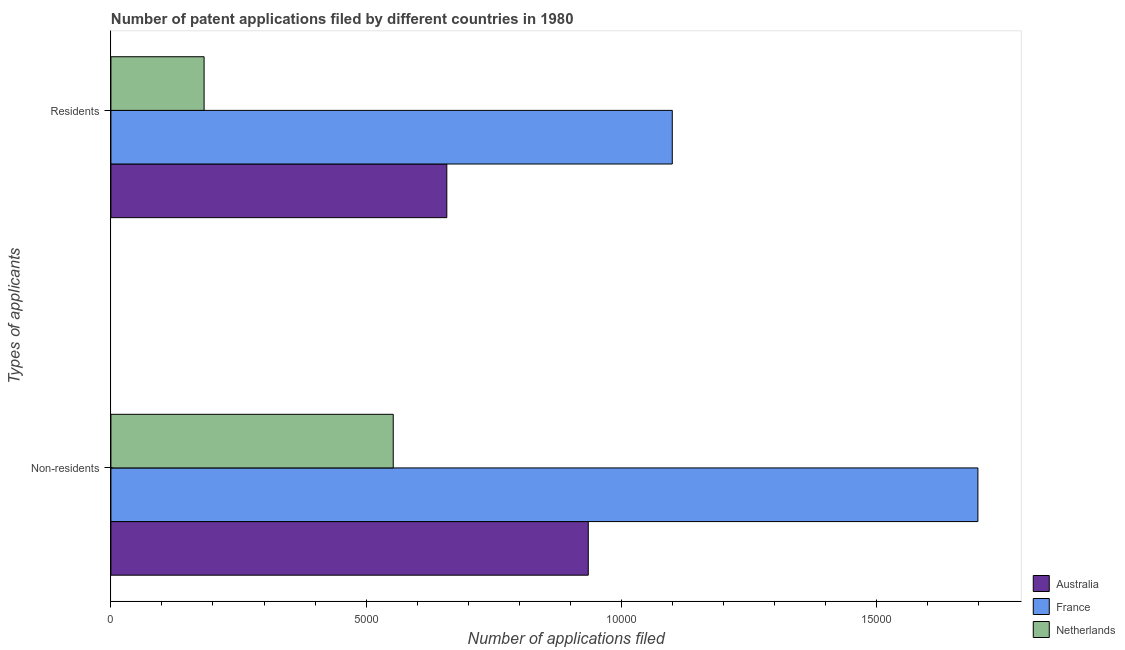How many different coloured bars are there?
Ensure brevity in your answer.  3. Are the number of bars per tick equal to the number of legend labels?
Your answer should be very brief. Yes. Are the number of bars on each tick of the Y-axis equal?
Your answer should be compact. Yes. What is the label of the 2nd group of bars from the top?
Keep it short and to the point. Non-residents. What is the number of patent applications by non residents in Australia?
Offer a very short reply. 9354. Across all countries, what is the maximum number of patent applications by non residents?
Offer a terse response. 1.70e+04. Across all countries, what is the minimum number of patent applications by residents?
Offer a very short reply. 1826. In which country was the number of patent applications by non residents maximum?
Keep it short and to the point. France. What is the total number of patent applications by residents in the graph?
Keep it short and to the point. 1.94e+04. What is the difference between the number of patent applications by residents in France and that in Netherlands?
Keep it short and to the point. 9174. What is the difference between the number of patent applications by residents in Australia and the number of patent applications by non residents in France?
Offer a terse response. -1.04e+04. What is the average number of patent applications by non residents per country?
Offer a terse response. 1.06e+04. What is the difference between the number of patent applications by residents and number of patent applications by non residents in France?
Provide a succinct answer. -5989. In how many countries, is the number of patent applications by non residents greater than 12000 ?
Provide a short and direct response. 1. What is the ratio of the number of patent applications by non residents in Australia to that in France?
Offer a terse response. 0.55. In how many countries, is the number of patent applications by residents greater than the average number of patent applications by residents taken over all countries?
Give a very brief answer. 2. What does the 1st bar from the top in Residents represents?
Your response must be concise. Netherlands. How many bars are there?
Your response must be concise. 6. What is the difference between two consecutive major ticks on the X-axis?
Give a very brief answer. 5000. Are the values on the major ticks of X-axis written in scientific E-notation?
Ensure brevity in your answer.  No. Does the graph contain grids?
Your answer should be compact. No. What is the title of the graph?
Provide a succinct answer. Number of patent applications filed by different countries in 1980. What is the label or title of the X-axis?
Your response must be concise. Number of applications filed. What is the label or title of the Y-axis?
Provide a short and direct response. Types of applicants. What is the Number of applications filed of Australia in Non-residents?
Make the answer very short. 9354. What is the Number of applications filed of France in Non-residents?
Provide a short and direct response. 1.70e+04. What is the Number of applications filed of Netherlands in Non-residents?
Your response must be concise. 5532. What is the Number of applications filed of Australia in Residents?
Provide a short and direct response. 6582. What is the Number of applications filed in France in Residents?
Offer a very short reply. 1.10e+04. What is the Number of applications filed in Netherlands in Residents?
Offer a very short reply. 1826. Across all Types of applicants, what is the maximum Number of applications filed of Australia?
Provide a short and direct response. 9354. Across all Types of applicants, what is the maximum Number of applications filed of France?
Offer a very short reply. 1.70e+04. Across all Types of applicants, what is the maximum Number of applications filed of Netherlands?
Ensure brevity in your answer.  5532. Across all Types of applicants, what is the minimum Number of applications filed in Australia?
Your response must be concise. 6582. Across all Types of applicants, what is the minimum Number of applications filed of France?
Keep it short and to the point. 1.10e+04. Across all Types of applicants, what is the minimum Number of applications filed in Netherlands?
Offer a terse response. 1826. What is the total Number of applications filed in Australia in the graph?
Keep it short and to the point. 1.59e+04. What is the total Number of applications filed of France in the graph?
Keep it short and to the point. 2.80e+04. What is the total Number of applications filed in Netherlands in the graph?
Provide a succinct answer. 7358. What is the difference between the Number of applications filed of Australia in Non-residents and that in Residents?
Your answer should be very brief. 2772. What is the difference between the Number of applications filed in France in Non-residents and that in Residents?
Offer a terse response. 5989. What is the difference between the Number of applications filed of Netherlands in Non-residents and that in Residents?
Offer a terse response. 3706. What is the difference between the Number of applications filed in Australia in Non-residents and the Number of applications filed in France in Residents?
Give a very brief answer. -1646. What is the difference between the Number of applications filed in Australia in Non-residents and the Number of applications filed in Netherlands in Residents?
Offer a terse response. 7528. What is the difference between the Number of applications filed in France in Non-residents and the Number of applications filed in Netherlands in Residents?
Your response must be concise. 1.52e+04. What is the average Number of applications filed in Australia per Types of applicants?
Provide a short and direct response. 7968. What is the average Number of applications filed of France per Types of applicants?
Ensure brevity in your answer.  1.40e+04. What is the average Number of applications filed of Netherlands per Types of applicants?
Your answer should be compact. 3679. What is the difference between the Number of applications filed of Australia and Number of applications filed of France in Non-residents?
Offer a very short reply. -7635. What is the difference between the Number of applications filed in Australia and Number of applications filed in Netherlands in Non-residents?
Your answer should be very brief. 3822. What is the difference between the Number of applications filed in France and Number of applications filed in Netherlands in Non-residents?
Your answer should be compact. 1.15e+04. What is the difference between the Number of applications filed in Australia and Number of applications filed in France in Residents?
Your answer should be very brief. -4418. What is the difference between the Number of applications filed of Australia and Number of applications filed of Netherlands in Residents?
Keep it short and to the point. 4756. What is the difference between the Number of applications filed of France and Number of applications filed of Netherlands in Residents?
Provide a short and direct response. 9174. What is the ratio of the Number of applications filed of Australia in Non-residents to that in Residents?
Your answer should be very brief. 1.42. What is the ratio of the Number of applications filed in France in Non-residents to that in Residents?
Make the answer very short. 1.54. What is the ratio of the Number of applications filed of Netherlands in Non-residents to that in Residents?
Make the answer very short. 3.03. What is the difference between the highest and the second highest Number of applications filed in Australia?
Provide a succinct answer. 2772. What is the difference between the highest and the second highest Number of applications filed of France?
Your answer should be compact. 5989. What is the difference between the highest and the second highest Number of applications filed of Netherlands?
Your answer should be compact. 3706. What is the difference between the highest and the lowest Number of applications filed of Australia?
Provide a short and direct response. 2772. What is the difference between the highest and the lowest Number of applications filed of France?
Offer a very short reply. 5989. What is the difference between the highest and the lowest Number of applications filed of Netherlands?
Offer a terse response. 3706. 